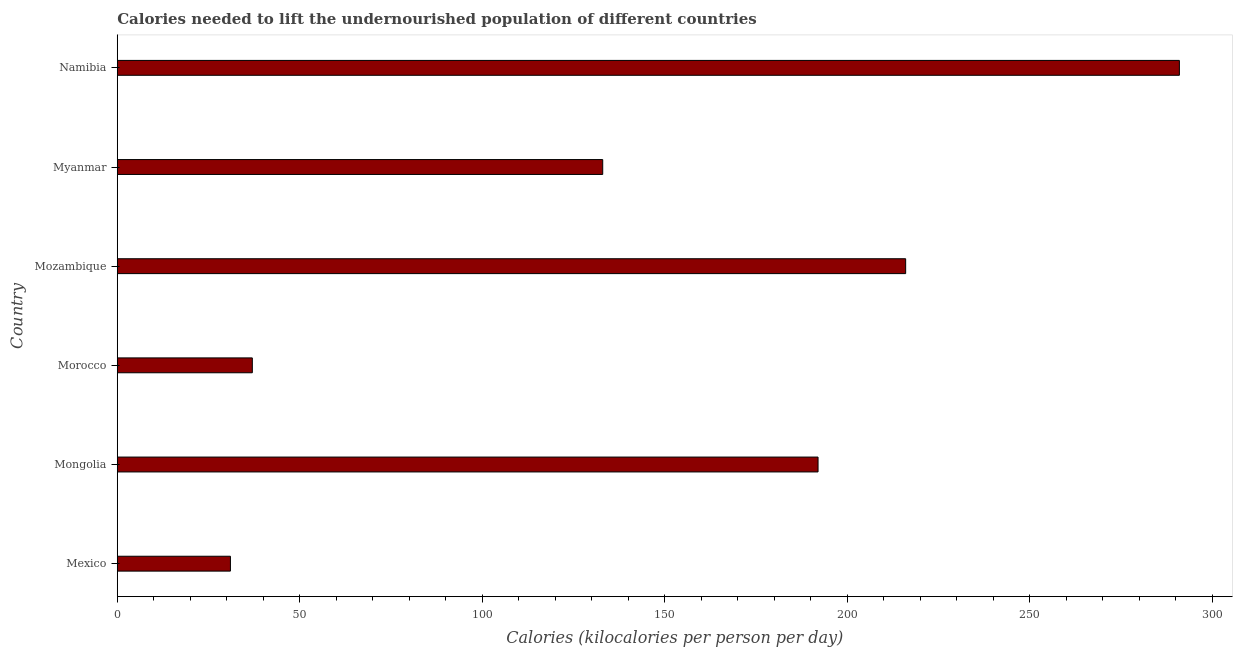Does the graph contain any zero values?
Your response must be concise. No. Does the graph contain grids?
Keep it short and to the point. No. What is the title of the graph?
Offer a very short reply. Calories needed to lift the undernourished population of different countries. What is the label or title of the X-axis?
Provide a succinct answer. Calories (kilocalories per person per day). What is the label or title of the Y-axis?
Offer a very short reply. Country. What is the depth of food deficit in Myanmar?
Make the answer very short. 133. Across all countries, what is the maximum depth of food deficit?
Provide a succinct answer. 291. Across all countries, what is the minimum depth of food deficit?
Your answer should be compact. 31. In which country was the depth of food deficit maximum?
Your response must be concise. Namibia. In which country was the depth of food deficit minimum?
Provide a short and direct response. Mexico. What is the sum of the depth of food deficit?
Ensure brevity in your answer.  900. What is the difference between the depth of food deficit in Mexico and Myanmar?
Keep it short and to the point. -102. What is the average depth of food deficit per country?
Provide a short and direct response. 150. What is the median depth of food deficit?
Offer a terse response. 162.5. In how many countries, is the depth of food deficit greater than 80 kilocalories?
Your answer should be compact. 4. What is the ratio of the depth of food deficit in Mongolia to that in Mozambique?
Keep it short and to the point. 0.89. Is the depth of food deficit in Mexico less than that in Mozambique?
Offer a very short reply. Yes. What is the difference between the highest and the second highest depth of food deficit?
Your answer should be very brief. 75. What is the difference between the highest and the lowest depth of food deficit?
Offer a very short reply. 260. In how many countries, is the depth of food deficit greater than the average depth of food deficit taken over all countries?
Provide a succinct answer. 3. How many countries are there in the graph?
Offer a very short reply. 6. What is the difference between two consecutive major ticks on the X-axis?
Give a very brief answer. 50. Are the values on the major ticks of X-axis written in scientific E-notation?
Your answer should be compact. No. What is the Calories (kilocalories per person per day) in Mexico?
Provide a succinct answer. 31. What is the Calories (kilocalories per person per day) of Mongolia?
Keep it short and to the point. 192. What is the Calories (kilocalories per person per day) in Morocco?
Ensure brevity in your answer.  37. What is the Calories (kilocalories per person per day) in Mozambique?
Keep it short and to the point. 216. What is the Calories (kilocalories per person per day) of Myanmar?
Ensure brevity in your answer.  133. What is the Calories (kilocalories per person per day) in Namibia?
Make the answer very short. 291. What is the difference between the Calories (kilocalories per person per day) in Mexico and Mongolia?
Offer a terse response. -161. What is the difference between the Calories (kilocalories per person per day) in Mexico and Morocco?
Give a very brief answer. -6. What is the difference between the Calories (kilocalories per person per day) in Mexico and Mozambique?
Offer a terse response. -185. What is the difference between the Calories (kilocalories per person per day) in Mexico and Myanmar?
Offer a very short reply. -102. What is the difference between the Calories (kilocalories per person per day) in Mexico and Namibia?
Provide a short and direct response. -260. What is the difference between the Calories (kilocalories per person per day) in Mongolia and Morocco?
Your response must be concise. 155. What is the difference between the Calories (kilocalories per person per day) in Mongolia and Mozambique?
Your response must be concise. -24. What is the difference between the Calories (kilocalories per person per day) in Mongolia and Myanmar?
Provide a succinct answer. 59. What is the difference between the Calories (kilocalories per person per day) in Mongolia and Namibia?
Give a very brief answer. -99. What is the difference between the Calories (kilocalories per person per day) in Morocco and Mozambique?
Offer a terse response. -179. What is the difference between the Calories (kilocalories per person per day) in Morocco and Myanmar?
Your answer should be very brief. -96. What is the difference between the Calories (kilocalories per person per day) in Morocco and Namibia?
Offer a terse response. -254. What is the difference between the Calories (kilocalories per person per day) in Mozambique and Namibia?
Provide a succinct answer. -75. What is the difference between the Calories (kilocalories per person per day) in Myanmar and Namibia?
Ensure brevity in your answer.  -158. What is the ratio of the Calories (kilocalories per person per day) in Mexico to that in Mongolia?
Make the answer very short. 0.16. What is the ratio of the Calories (kilocalories per person per day) in Mexico to that in Morocco?
Offer a very short reply. 0.84. What is the ratio of the Calories (kilocalories per person per day) in Mexico to that in Mozambique?
Your answer should be compact. 0.14. What is the ratio of the Calories (kilocalories per person per day) in Mexico to that in Myanmar?
Make the answer very short. 0.23. What is the ratio of the Calories (kilocalories per person per day) in Mexico to that in Namibia?
Ensure brevity in your answer.  0.11. What is the ratio of the Calories (kilocalories per person per day) in Mongolia to that in Morocco?
Provide a succinct answer. 5.19. What is the ratio of the Calories (kilocalories per person per day) in Mongolia to that in Mozambique?
Keep it short and to the point. 0.89. What is the ratio of the Calories (kilocalories per person per day) in Mongolia to that in Myanmar?
Make the answer very short. 1.44. What is the ratio of the Calories (kilocalories per person per day) in Mongolia to that in Namibia?
Keep it short and to the point. 0.66. What is the ratio of the Calories (kilocalories per person per day) in Morocco to that in Mozambique?
Your response must be concise. 0.17. What is the ratio of the Calories (kilocalories per person per day) in Morocco to that in Myanmar?
Make the answer very short. 0.28. What is the ratio of the Calories (kilocalories per person per day) in Morocco to that in Namibia?
Your response must be concise. 0.13. What is the ratio of the Calories (kilocalories per person per day) in Mozambique to that in Myanmar?
Your answer should be very brief. 1.62. What is the ratio of the Calories (kilocalories per person per day) in Mozambique to that in Namibia?
Provide a short and direct response. 0.74. What is the ratio of the Calories (kilocalories per person per day) in Myanmar to that in Namibia?
Offer a very short reply. 0.46. 